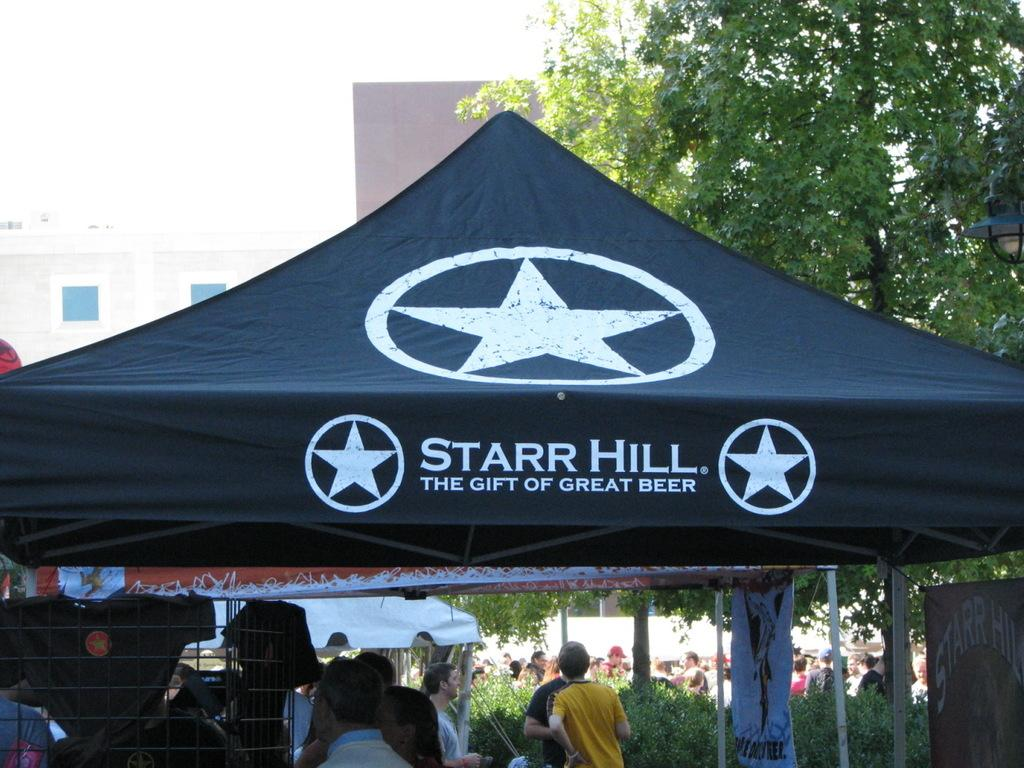What is happening in the image? There is a group of people standing in the image. What can be seen in the background of the image? There are trees and buildings in the background of the image. What type of polish is the boy applying to his face in the image? There is no boy or polish present in the image; it features a group of people standing with trees and buildings in the background. 